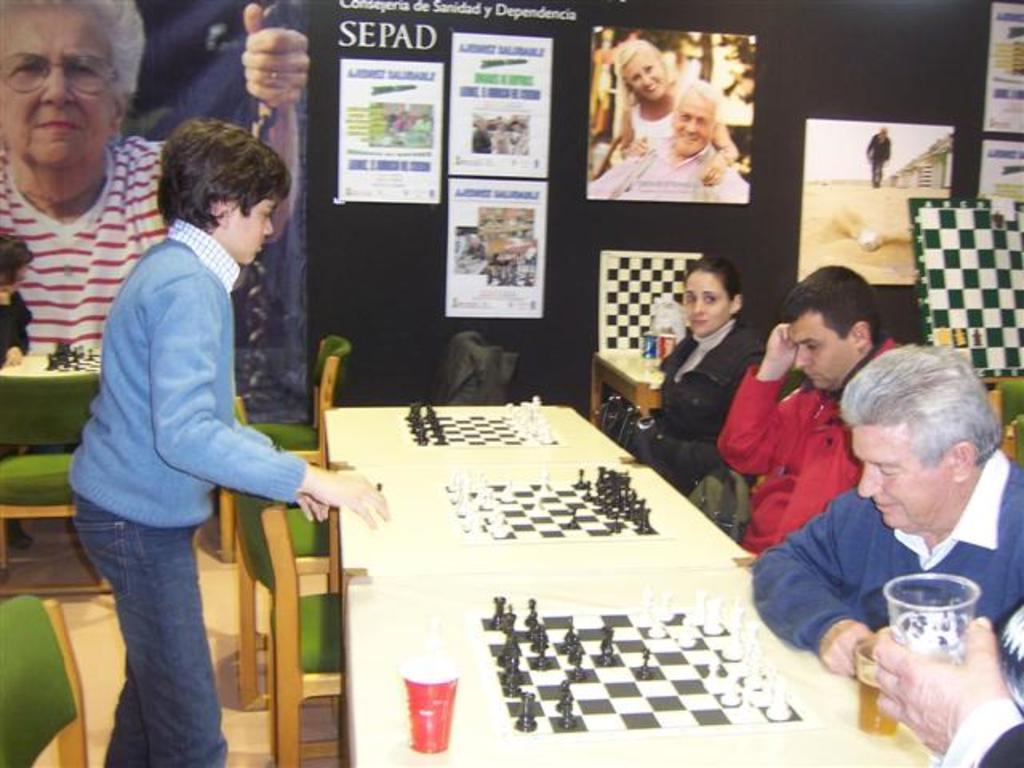Please provide a concise description of this image. This picture is of inside the room. On the right there are group of persons sitting on the chairs. On the left there is a boy standing and there are many number of chairs. In the center there are tables on the top of which glasses and chess boards are placed. In the background we can see a wall, many wall posters including the picture of man and woman. On the left there is a banner with a picture of a woman wearing white color t-shirt and there is a table on the top of which some items are placed. 